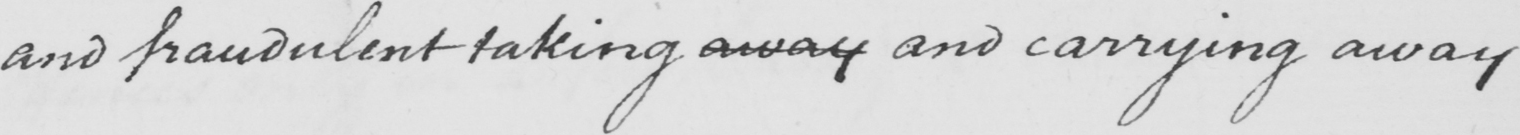What is written in this line of handwriting? and fraudulent taking away and carrying away 